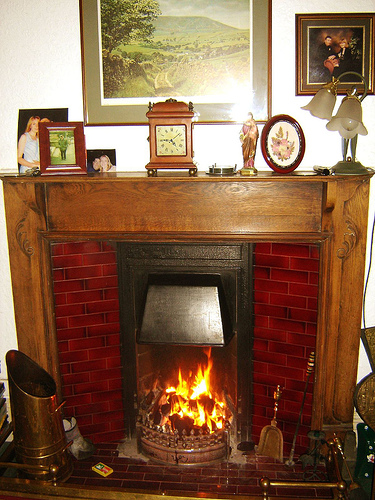<image>
Is there a picture behind the lamp? Yes. From this viewpoint, the picture is positioned behind the lamp, with the lamp partially or fully occluding the picture. Is the fire in front of the clock? No. The fire is not in front of the clock. The spatial positioning shows a different relationship between these objects. 